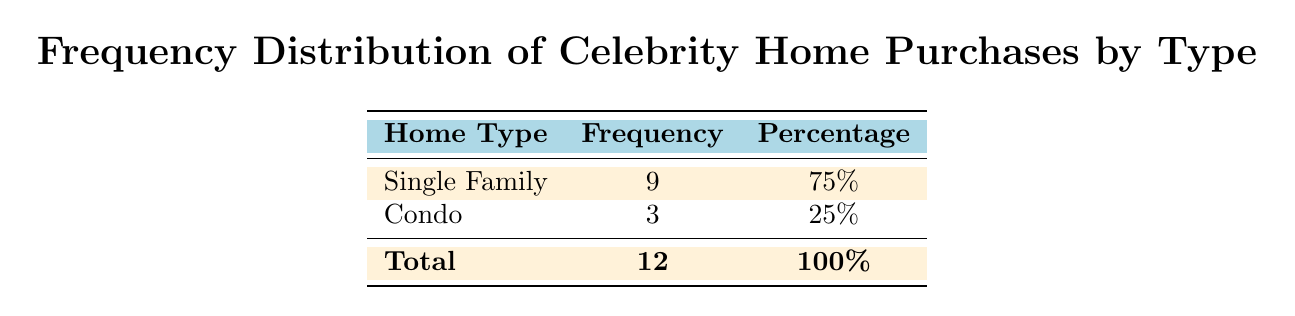What is the total number of celebrity home purchases recorded? The table indicates that the total number of purchases is listed as 12.
Answer: 12 What percentage of celebrity home purchases are Single Family homes? The table shows that 9 out of 12 purchases are Single Family homes, which is calculated as (9/12)*100 = 75%.
Answer: 75% Is there any instance of a celebrity purchasing a Condo in 2020? The table lists three Condo purchases, but only one (Lady Gaga) occurred in 2020.
Answer: Yes How many more Single Family homes are there compared to Condos? The table displays 9 Single Family homes and 3 Condos. The difference is calculated as 9 - 3 = 6.
Answer: 6 What is the average price of Single Family homes purchased by celebrities? To find the average price, we first sum the prices of the Single Family homes: 36.5 + 15.8 + 10.0 + 6.7 + 8.5 + 8.1 + 7.5 + 60.0 + 16.0 = 169.1. Then, we divide by the number of Single Family purchases, which is 9. Thus, the average price is 169.1 / 9 ≈ 18.79 million.
Answer: 18.79 million Did any of the celebrities purchase a Condo in 2021? The table shows one Condo purchase by Courteney Cox listed for the year 2021.
Answer: Yes What proportion of the total purchases does each home type represent? The Single Family homes make up 9/12 = 75%, and the Condos make up 3/12 = 25% of the total purchases.
Answer: 75% for Single Family, 25% for Condo If there were one more celebrity purchasing a Condo in 2022, how would that affect the frequency distribution? Currently, with 3 Condos out of 12 purchases, adding one more Condo would increase the total to 13, and the new count would be 9 Single Family and 4 Condos. The new percentage for Condos would be (4/13)*100 ≈ 30.77% and for Single Family (9/13)*100 ≈ 69.23%.
Answer: 30.77% for Condo, 69.23% for Single Family 